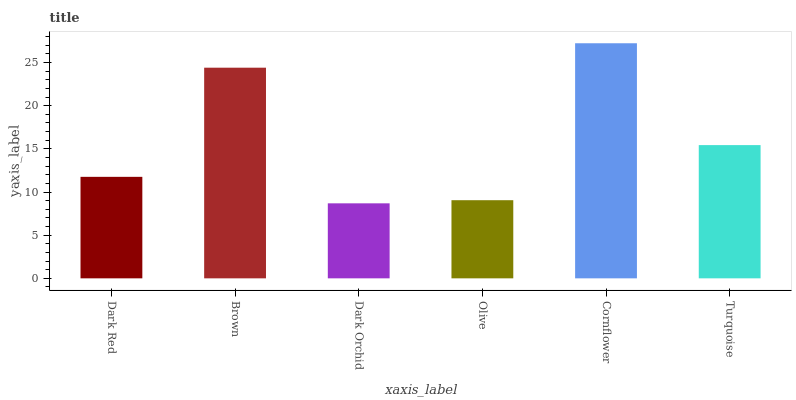Is Dark Orchid the minimum?
Answer yes or no. Yes. Is Cornflower the maximum?
Answer yes or no. Yes. Is Brown the minimum?
Answer yes or no. No. Is Brown the maximum?
Answer yes or no. No. Is Brown greater than Dark Red?
Answer yes or no. Yes. Is Dark Red less than Brown?
Answer yes or no. Yes. Is Dark Red greater than Brown?
Answer yes or no. No. Is Brown less than Dark Red?
Answer yes or no. No. Is Turquoise the high median?
Answer yes or no. Yes. Is Dark Red the low median?
Answer yes or no. Yes. Is Olive the high median?
Answer yes or no. No. Is Cornflower the low median?
Answer yes or no. No. 